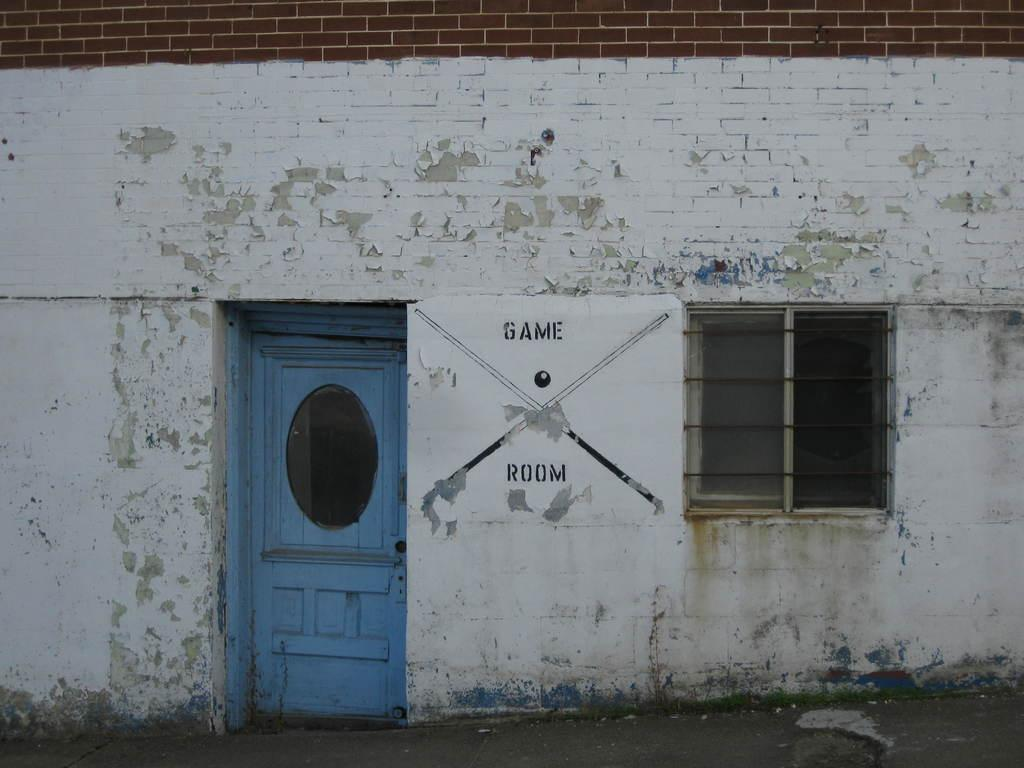What is a prominent feature of the wall in the image? There is a door in the wall. Are there any other openings in the wall besides the door? Yes, there is a window in the wall. What is attached to the wall in the image? There is a poster attached to the wall. What type of cap can be seen on the poster in the image? There is no cap present on the poster in the image. How does the kite affect the appearance of the wall in the image? There is no kite present in the image, so it does not affect the appearance of the wall. 